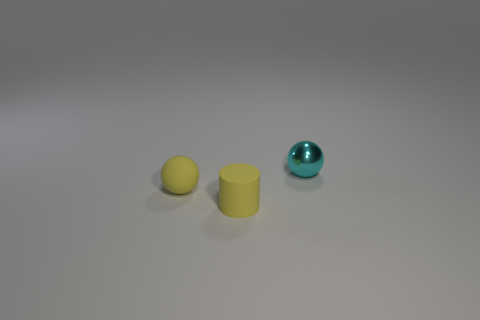How many balls are both right of the yellow ball and on the left side of the cyan metallic object?
Provide a short and direct response. 0. What number of spheres are either cyan matte things or metal things?
Your answer should be very brief. 1. Is there a big brown metal sphere?
Provide a succinct answer. No. What number of other things are there of the same material as the cylinder
Give a very brief answer. 1. What is the material of the yellow cylinder that is the same size as the rubber sphere?
Your response must be concise. Rubber. There is a small yellow rubber thing in front of the yellow matte sphere; is its shape the same as the tiny cyan object?
Ensure brevity in your answer.  No. Does the cylinder have the same color as the shiny sphere?
Give a very brief answer. No. How many objects are small rubber objects that are left of the cylinder or yellow matte objects?
Make the answer very short. 2. There is a yellow rubber thing that is the same size as the matte cylinder; what is its shape?
Provide a succinct answer. Sphere. Do the ball in front of the cyan thing and the matte cylinder in front of the yellow matte sphere have the same size?
Your answer should be compact. Yes. 